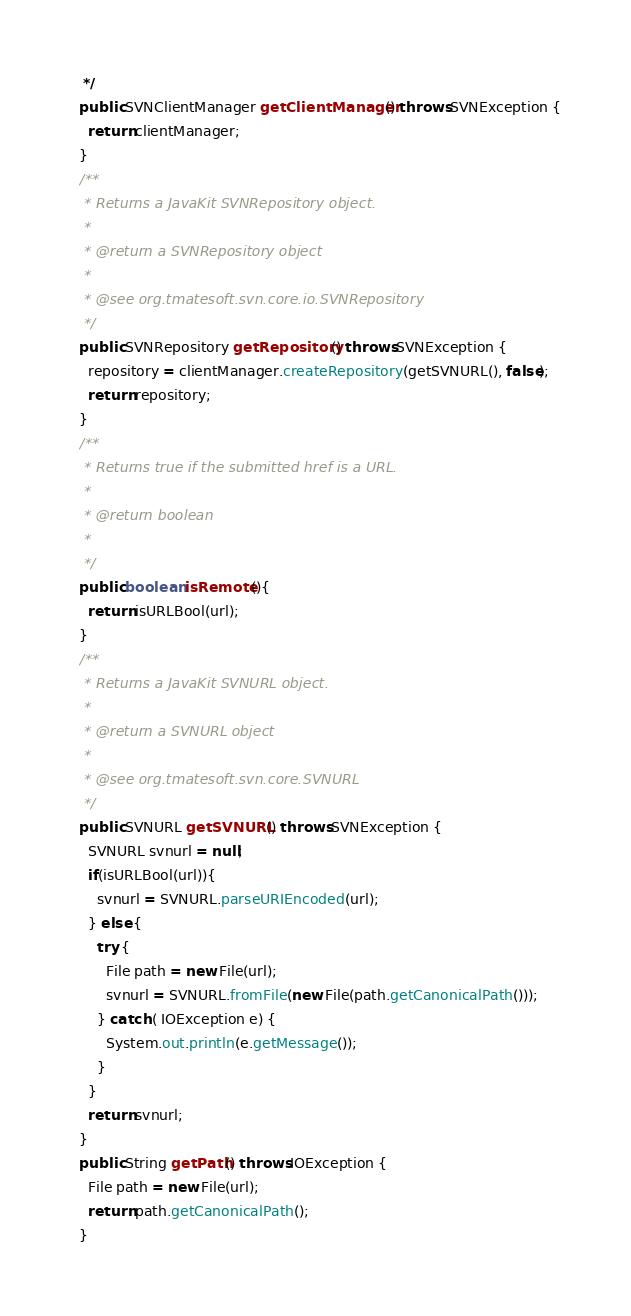Convert code to text. <code><loc_0><loc_0><loc_500><loc_500><_Java_>   */
  public SVNClientManager getClientManager() throws SVNException {
    return clientManager;
  }
  /**
   * Returns a JavaKit SVNRepository object. 
   *
   * @return a SVNRepository object
   *
   * @see org.tmatesoft.svn.core.io.SVNRepository
   */
  public SVNRepository getRepository() throws SVNException {
    repository = clientManager.createRepository(getSVNURL(), false);
    return repository;
  }
  /**
   * Returns true if the submitted href is a URL. 
   *
   * @return boolean
   *
   */
  public boolean isRemote(){
    return isURLBool(url);
  }
  /**
   * Returns a JavaKit SVNURL object. 
   * 
   * @return a SVNURL object
   * 
   * @see org.tmatesoft.svn.core.SVNURL
   */
  public SVNURL getSVNURL() throws SVNException {
    SVNURL svnurl = null;
    if(isURLBool(url)){
      svnurl = SVNURL.parseURIEncoded(url);
    } else {
      try {
        File path = new File(url);
        svnurl = SVNURL.fromFile(new File(path.getCanonicalPath()));
      } catch ( IOException e) {
        System.out.println(e.getMessage());
      }
    }
    return svnurl;
  }
  public String getPath() throws IOException {
    File path = new File(url);
    return path.getCanonicalPath();
  }</code> 